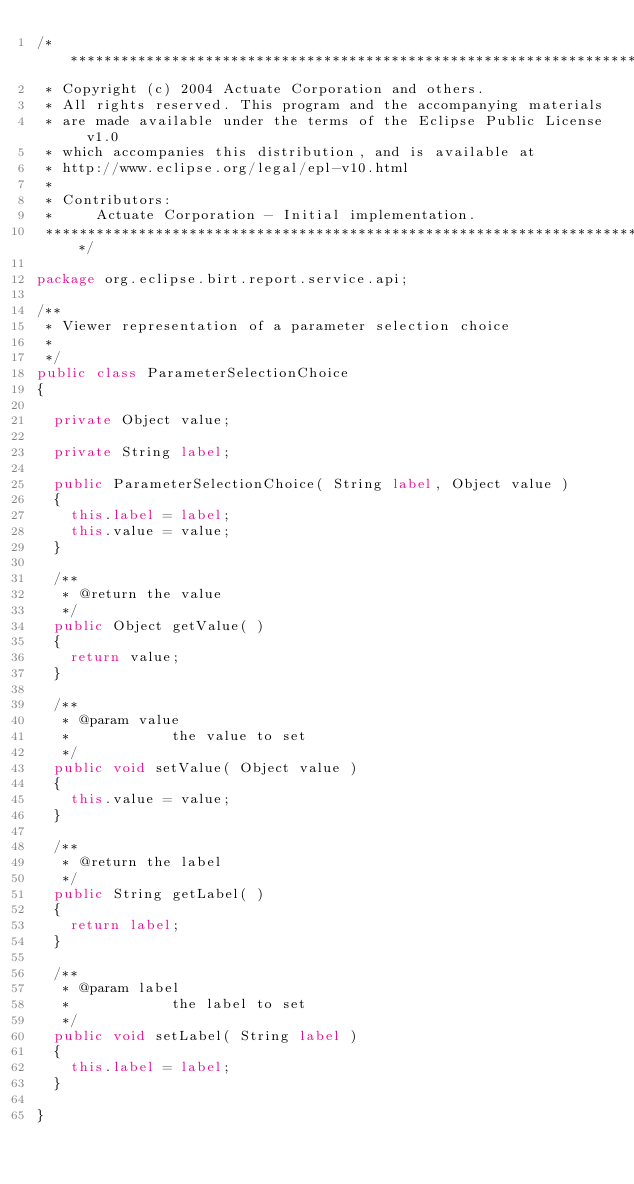<code> <loc_0><loc_0><loc_500><loc_500><_Java_>/*************************************************************************************
 * Copyright (c) 2004 Actuate Corporation and others.
 * All rights reserved. This program and the accompanying materials 
 * are made available under the terms of the Eclipse Public License v1.0
 * which accompanies this distribution, and is available at
 * http://www.eclipse.org/legal/epl-v10.html
 * 
 * Contributors:
 *     Actuate Corporation - Initial implementation.
 ************************************************************************************/

package org.eclipse.birt.report.service.api;

/**
 * Viewer representation of a parameter selection choice
 * 
 */
public class ParameterSelectionChoice
{

	private Object value;

	private String label;

	public ParameterSelectionChoice( String label, Object value )
	{
		this.label = label;
		this.value = value;
	}

	/**
	 * @return the value
	 */
	public Object getValue( )
	{
		return value;
	}

	/**
	 * @param value
	 *            the value to set
	 */
	public void setValue( Object value )
	{
		this.value = value;
	}

	/**
	 * @return the label
	 */
	public String getLabel( )
	{
		return label;
	}

	/**
	 * @param label
	 *            the label to set
	 */
	public void setLabel( String label )
	{
		this.label = label;
	}

}
</code> 